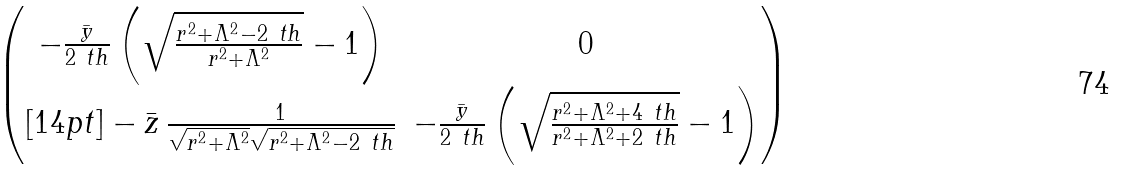<formula> <loc_0><loc_0><loc_500><loc_500>\begin{pmatrix} - \frac { \bar { y } } { 2 \ t h } \left ( \sqrt { \frac { r ^ { 2 } + \Lambda ^ { 2 } - 2 \ t h } { r ^ { 2 } + \Lambda ^ { 2 } } } - 1 \right ) & 0 \\ [ 1 4 p t ] - \bar { z } \, \frac { 1 } { \sqrt { r ^ { 2 } + \Lambda ^ { 2 } } \sqrt { r ^ { 2 } + \Lambda ^ { 2 } - 2 \ t h } } & - \frac { \bar { y } } { 2 \ t h } \left ( \sqrt { \frac { r ^ { 2 } + \Lambda ^ { 2 } + 4 \ t h } { r ^ { 2 } + \Lambda ^ { 2 } + 2 \ t h } } - 1 \right ) \end{pmatrix}</formula> 